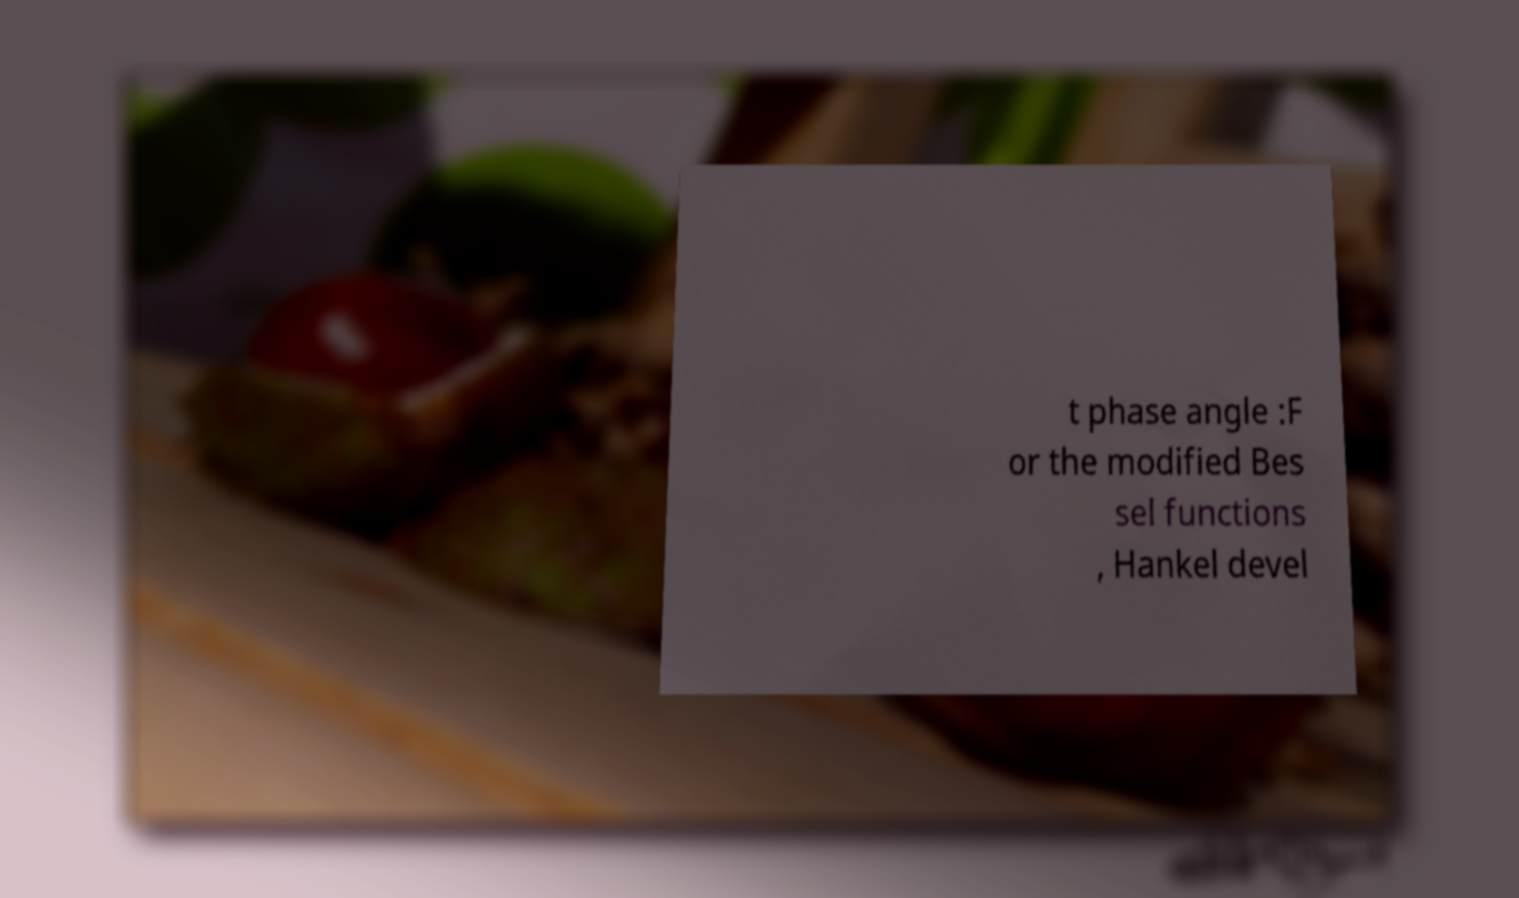Can you accurately transcribe the text from the provided image for me? t phase angle :F or the modified Bes sel functions , Hankel devel 